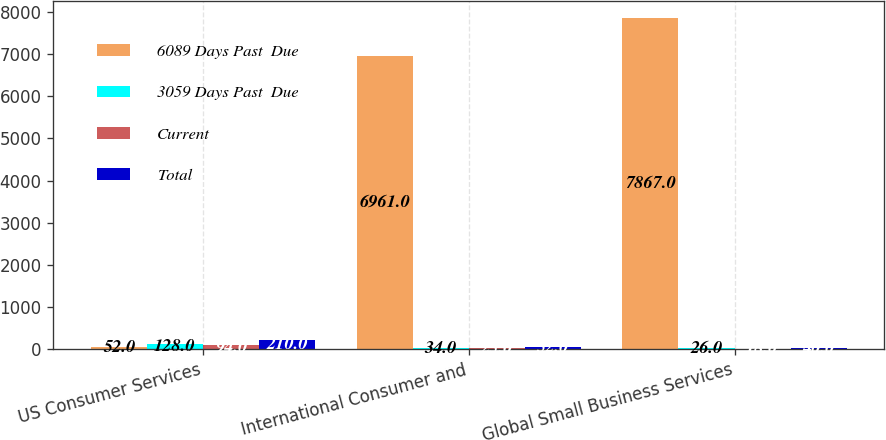Convert chart to OTSL. <chart><loc_0><loc_0><loc_500><loc_500><stacked_bar_chart><ecel><fcel>US Consumer Services<fcel>International Consumer and<fcel>Global Small Business Services<nl><fcel>6089 Days Past  Due<fcel>52<fcel>6961<fcel>7867<nl><fcel>3059 Days Past  Due<fcel>128<fcel>34<fcel>26<nl><fcel>Current<fcel>94<fcel>25<fcel>18<nl><fcel>Total<fcel>210<fcel>52<fcel>40<nl></chart> 